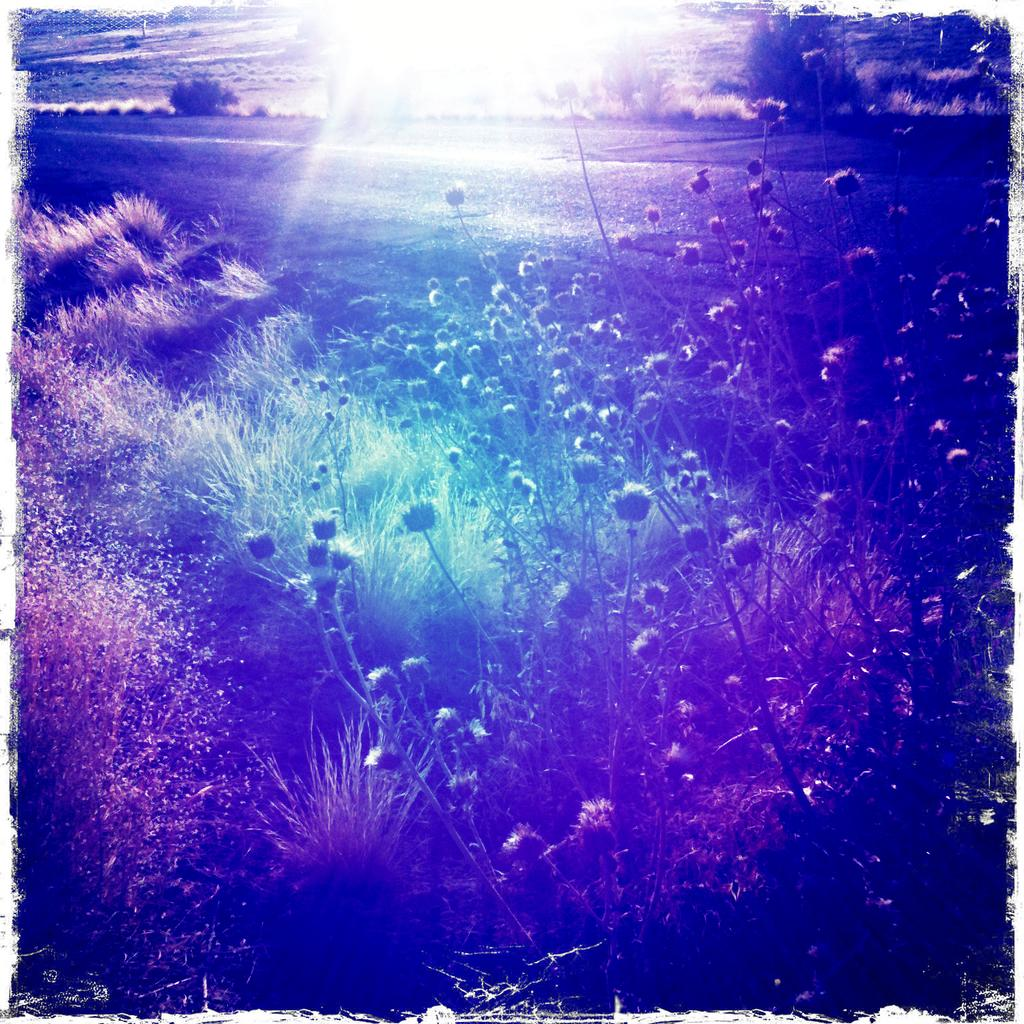What type of vegetation is present in the image? There is a group of plants, trees, and grass in the image. Can you describe the different types of plants in the image? The image contains a group of plants, which includes trees and grass. What is the natural environment depicted in the image? The natural environment depicted in the image includes plants, trees, and grass. What type of room can be seen in the image? There is no room present in the image; it features a natural environment with plants, trees, and grass. What type of hope can be seen in the image? There is no hope depicted in the image; it features a natural environment with plants, trees, and grass. 